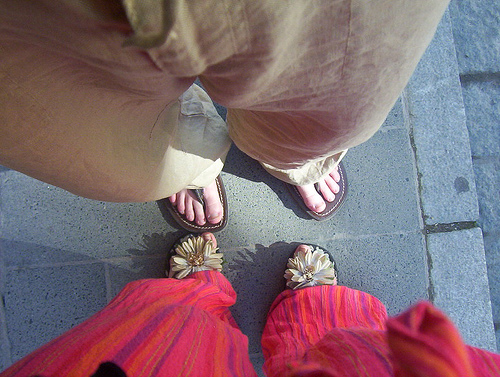<image>
Can you confirm if the red pants is behind the flower sandles? No. The red pants is not behind the flower sandles. From this viewpoint, the red pants appears to be positioned elsewhere in the scene. 